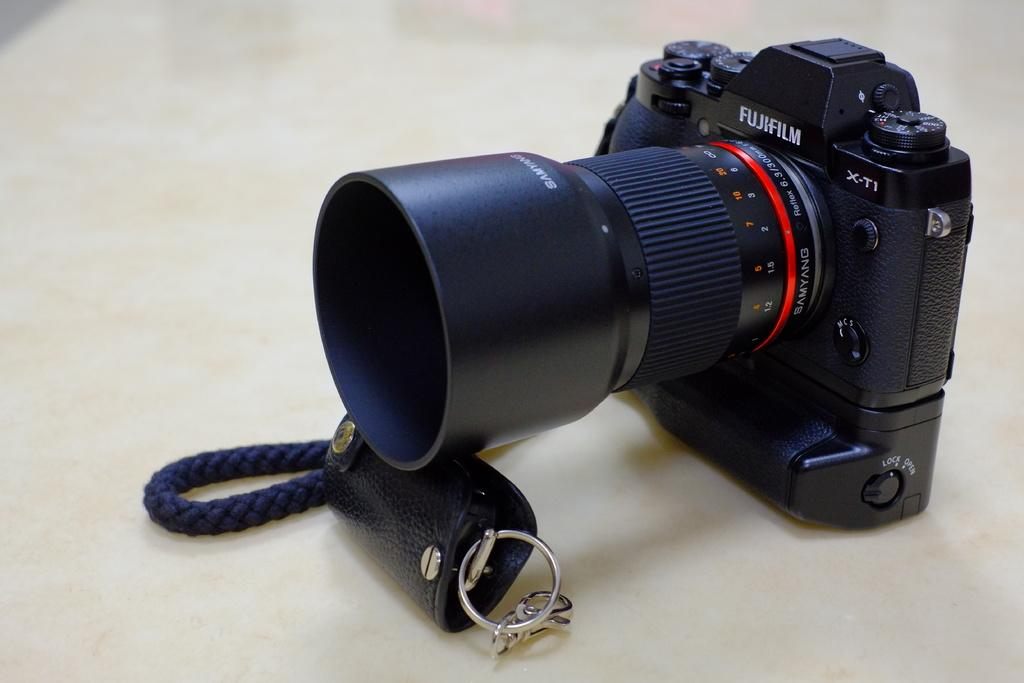<image>
Share a concise interpretation of the image provided. A Fujifilm camera with a long lens is propped up on a table. 